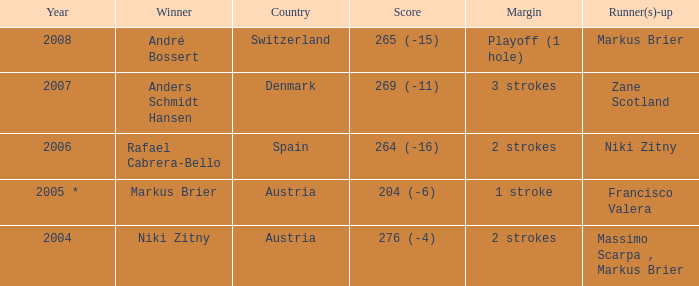Who was the runner-up when the margin was 1 stroke? Francisco Valera. 